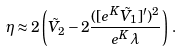<formula> <loc_0><loc_0><loc_500><loc_500>\eta \approx 2 \left ( \tilde { V } _ { 2 } - 2 \frac { ( [ e ^ { K } \tilde { V } _ { 1 } ] ^ { \prime } ) ^ { 2 } } { e ^ { K } \lambda } \right ) \, .</formula> 